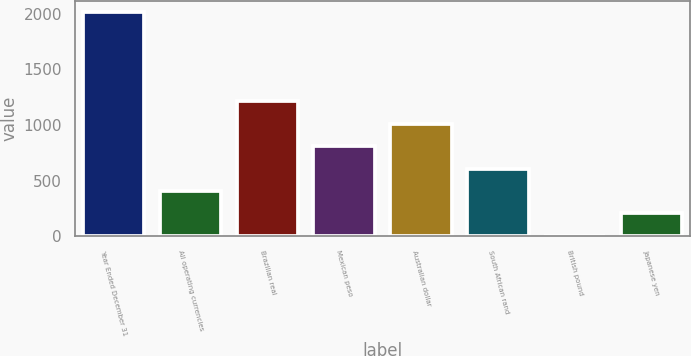Convert chart to OTSL. <chart><loc_0><loc_0><loc_500><loc_500><bar_chart><fcel>Year Ended December 31<fcel>All operating currencies<fcel>Brazilian real<fcel>Mexican peso<fcel>Australian dollar<fcel>South African rand<fcel>British pound<fcel>Japanese yen<nl><fcel>2015<fcel>409.4<fcel>1212.2<fcel>810.8<fcel>1011.5<fcel>610.1<fcel>8<fcel>208.7<nl></chart> 